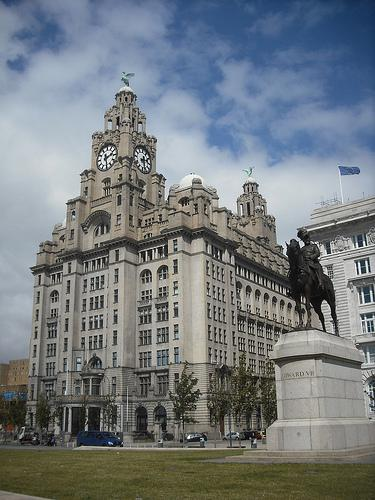Question: what color is the flag?
Choices:
A. Green and white.
B. Blue.
C. Red.
D. Yellow.
Answer with the letter. Answer: B Question: how many trees are in the photo?
Choices:
A. Two.
B. Four.
C. Eight.
D. Three.
Answer with the letter. Answer: C Question: how many clocks are visible?
Choices:
A. Two.
B. Three.
C. Four.
D. One.
Answer with the letter. Answer: A Question: where is the statue located?
Choices:
A. On the right hand side in the foreground.
B. By the building.
C. In front of the car.
D. Next to the boy.
Answer with the letter. Answer: A 